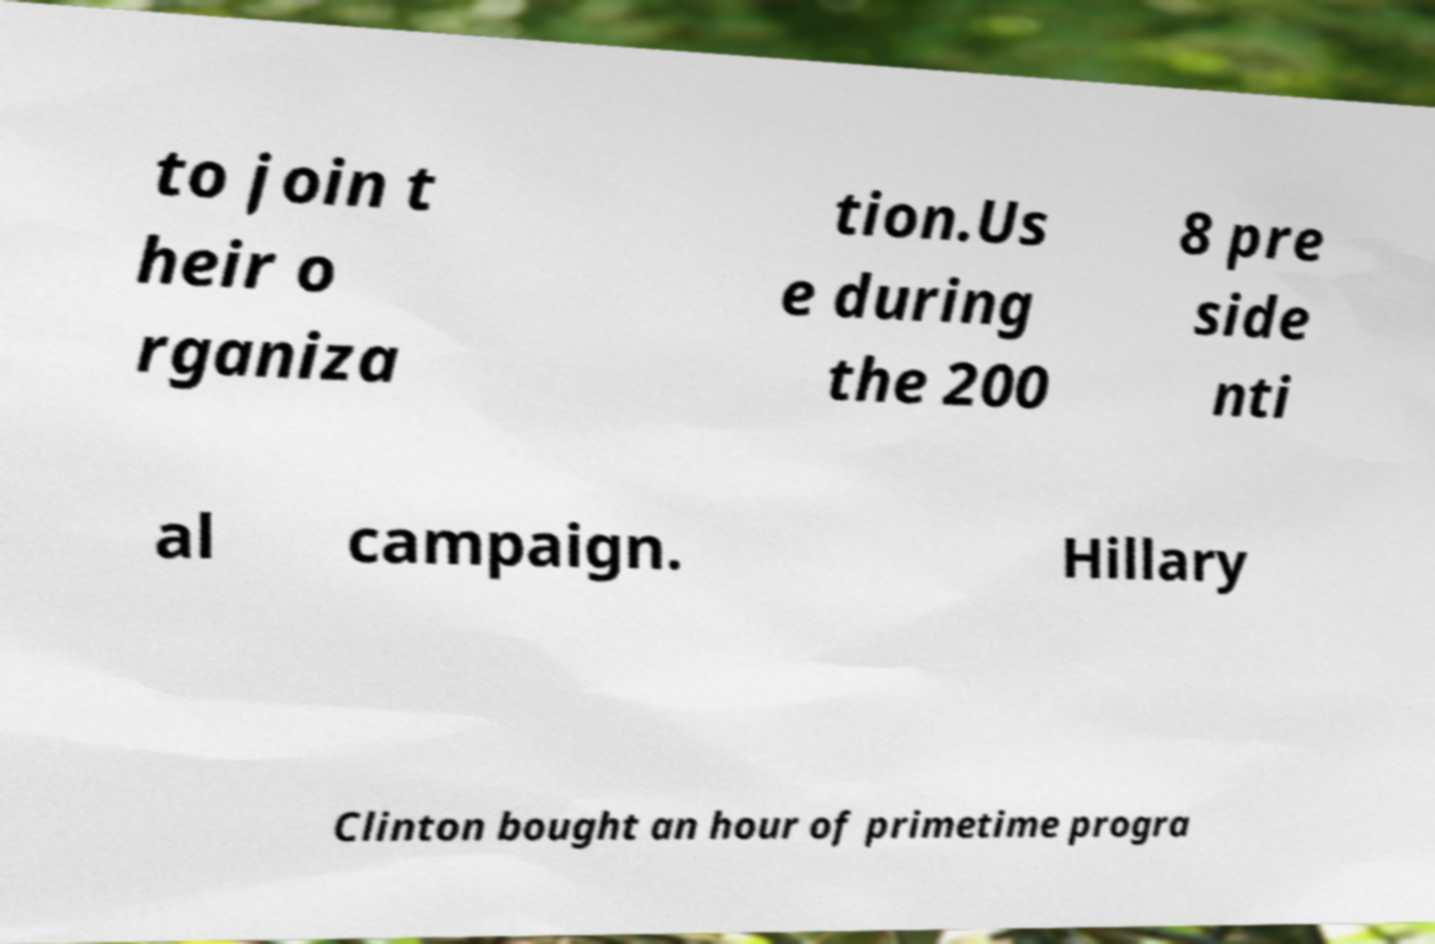There's text embedded in this image that I need extracted. Can you transcribe it verbatim? to join t heir o rganiza tion.Us e during the 200 8 pre side nti al campaign. Hillary Clinton bought an hour of primetime progra 